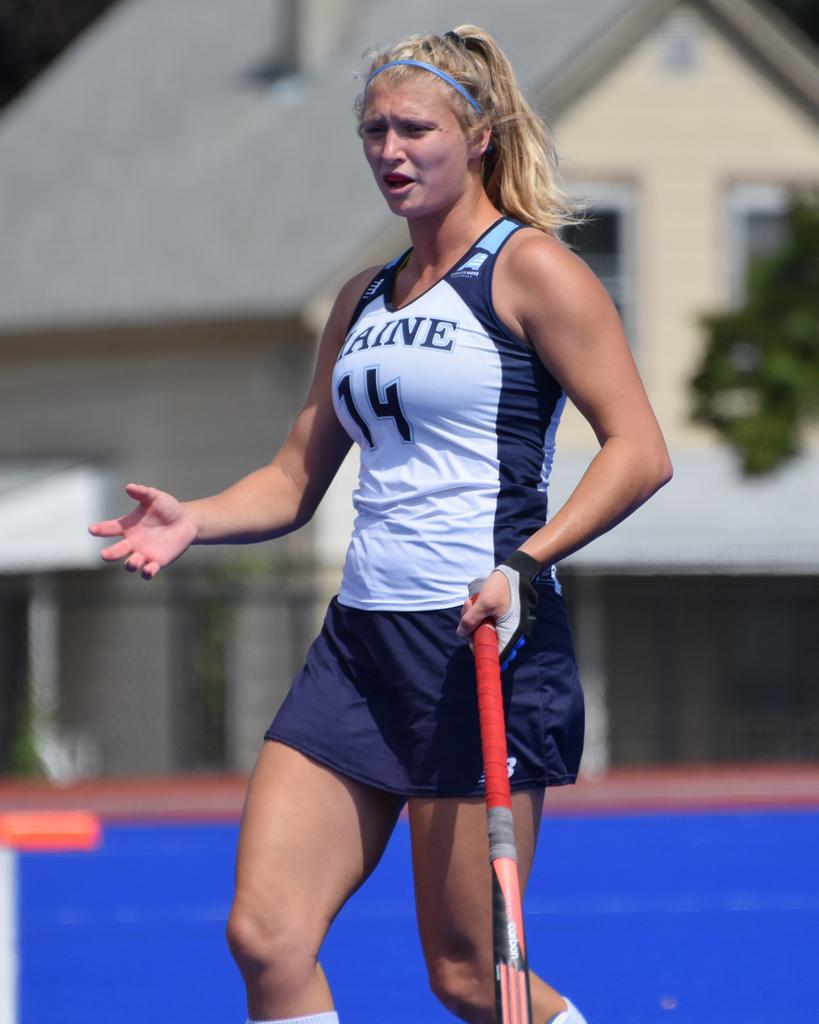<image>
Provide a brief description of the given image. Number 14 is upset about some unspecified happening on the field. 